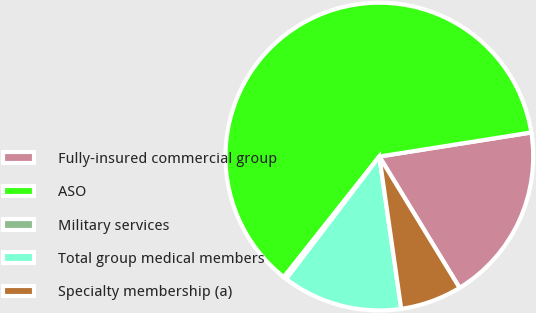Convert chart. <chart><loc_0><loc_0><loc_500><loc_500><pie_chart><fcel>Fully-insured commercial group<fcel>ASO<fcel>Military services<fcel>Total group medical members<fcel>Specialty membership (a)<nl><fcel>18.77%<fcel>61.84%<fcel>0.31%<fcel>12.62%<fcel>6.46%<nl></chart> 